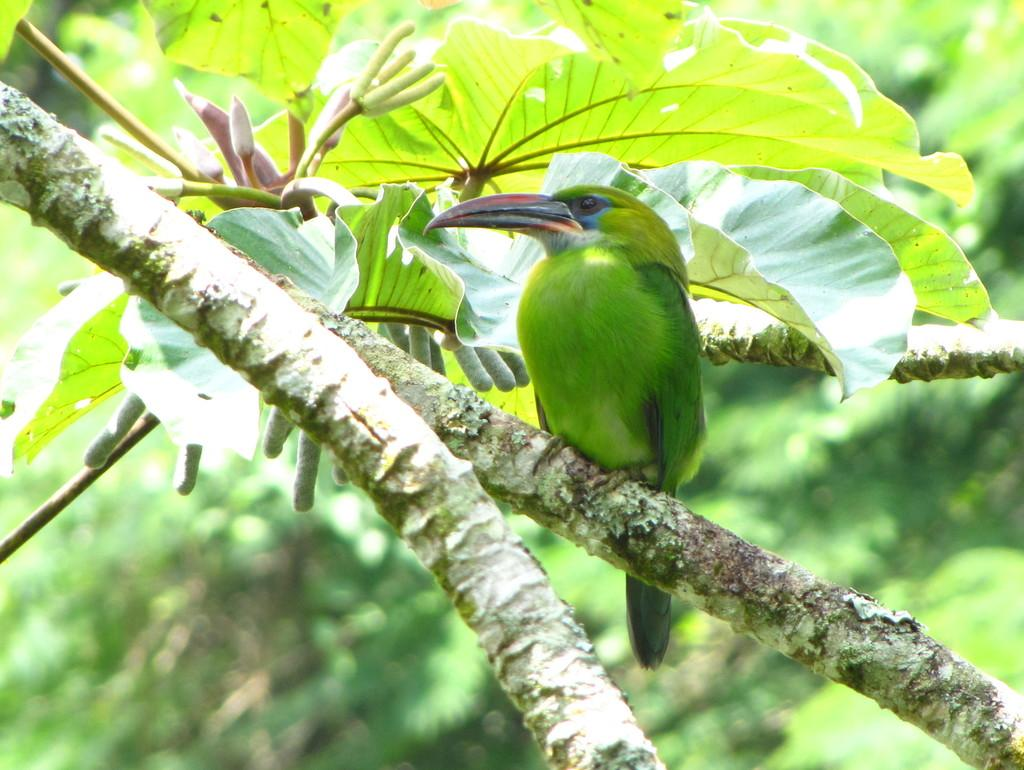What type of bird is in the image? There is an Emerald toucanet bird in the image. Where is the bird located in the image? The bird is on a tree branch. What can be seen in the background of the image? There are trees and leaves visible in the image. What is the color of the bird? The bird is green in color. What type of sweater is the bird wearing in the image? The bird is not wearing a sweater in the image; it is a bird and does not wear clothing. 